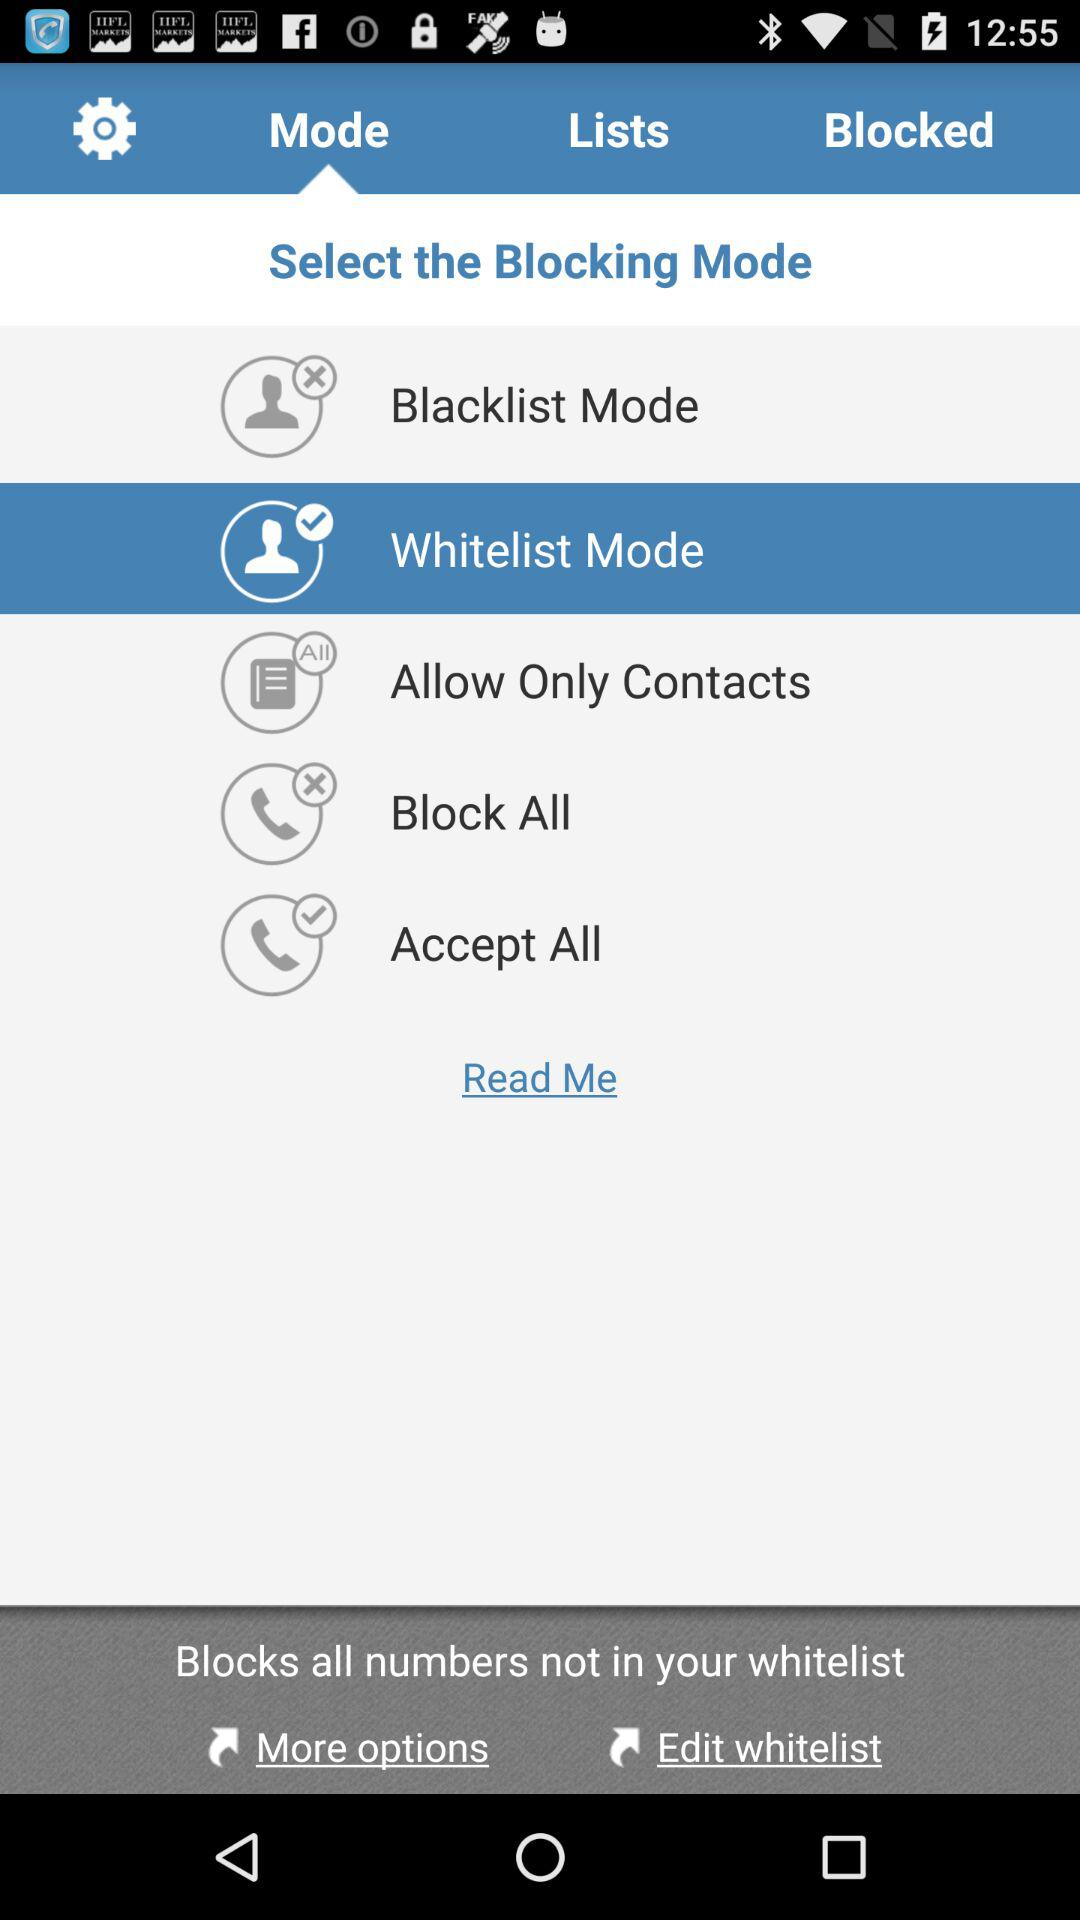Who has been blocked?
When the provided information is insufficient, respond with <no answer>. <no answer> 